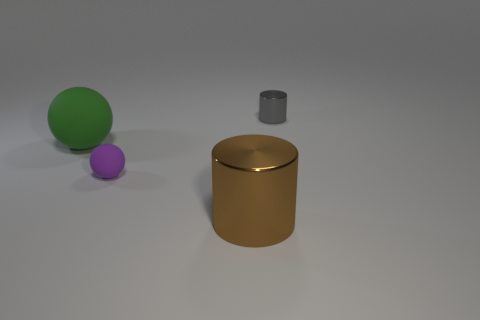The small thing that is the same material as the large brown object is what color?
Make the answer very short. Gray. What number of small gray cylinders have the same material as the brown cylinder?
Ensure brevity in your answer.  1. There is a rubber thing that is in front of the green rubber thing; is its size the same as the gray cylinder?
Offer a very short reply. Yes. What is the color of the other shiny thing that is the same size as the green thing?
Your answer should be compact. Brown. There is a gray metal cylinder; what number of small gray objects are to the right of it?
Provide a succinct answer. 0. Is there a gray rubber cylinder?
Ensure brevity in your answer.  No. There is a shiny thing in front of the cylinder behind the big brown metal cylinder that is on the left side of the gray object; how big is it?
Make the answer very short. Large. How many other objects are there of the same size as the gray metal cylinder?
Your answer should be very brief. 1. There is a cylinder that is in front of the small gray metallic cylinder; what is its size?
Provide a succinct answer. Large. Are there any other things that have the same color as the big shiny cylinder?
Offer a terse response. No. 